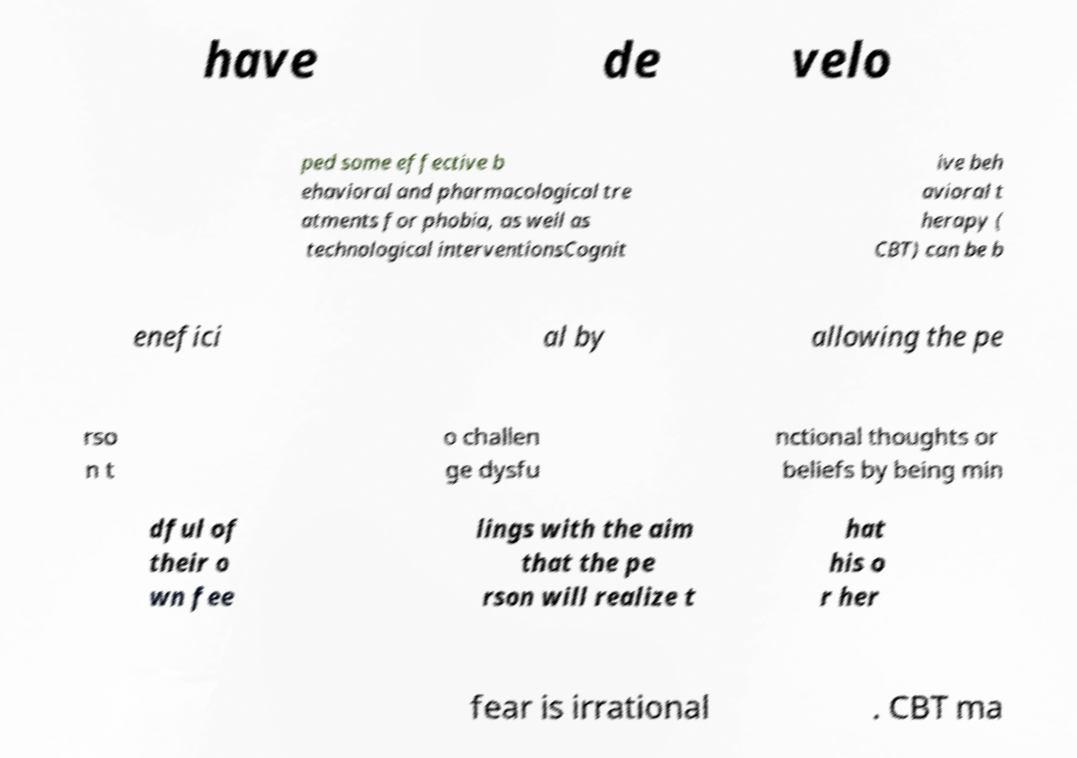Can you read and provide the text displayed in the image?This photo seems to have some interesting text. Can you extract and type it out for me? have de velo ped some effective b ehavioral and pharmacological tre atments for phobia, as well as technological interventionsCognit ive beh avioral t herapy ( CBT) can be b enefici al by allowing the pe rso n t o challen ge dysfu nctional thoughts or beliefs by being min dful of their o wn fee lings with the aim that the pe rson will realize t hat his o r her fear is irrational . CBT ma 